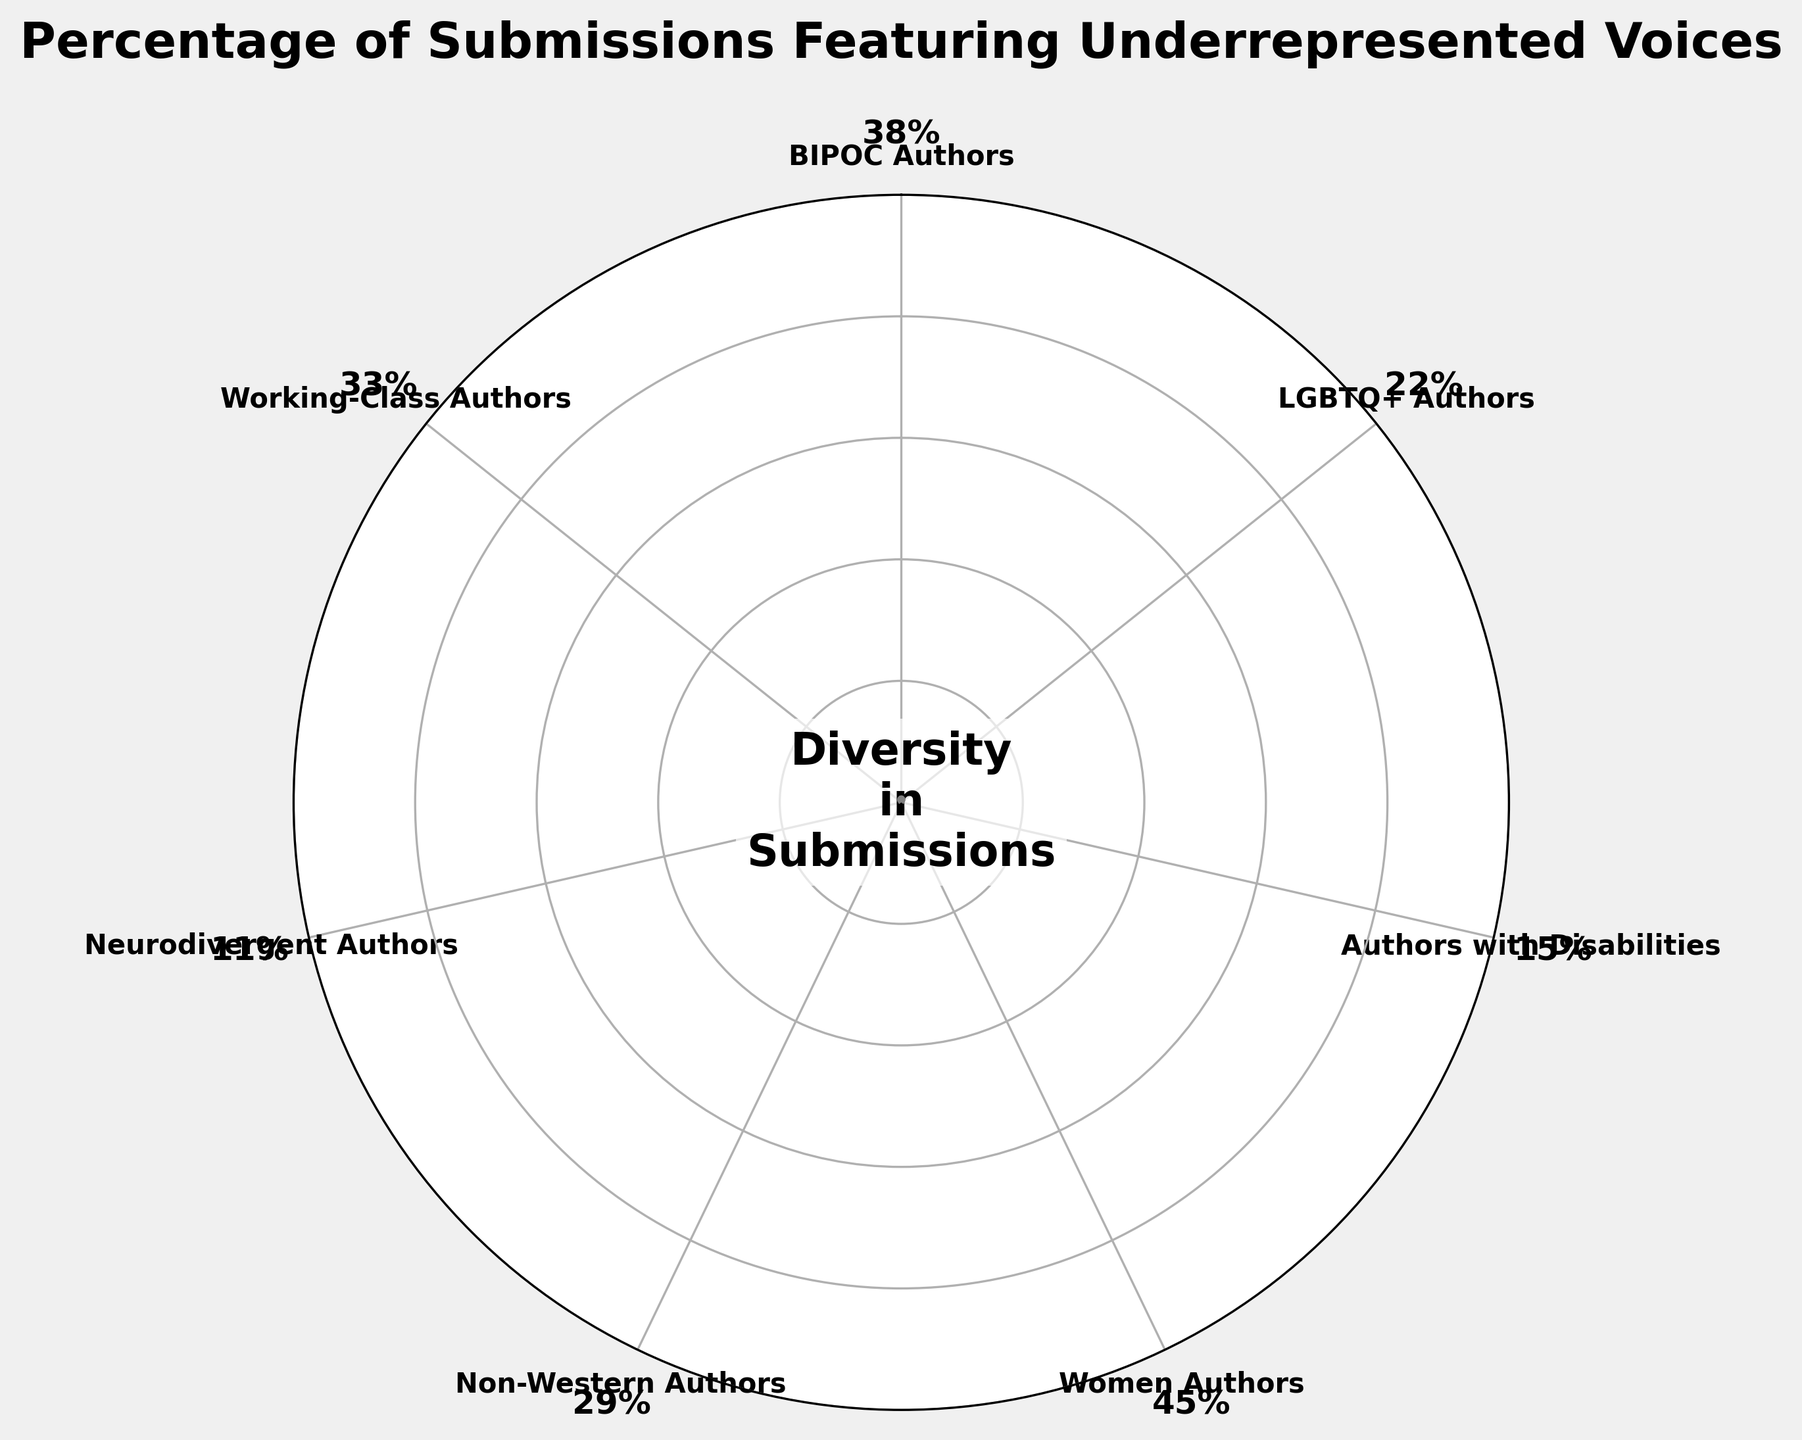What's the highest percentage shown in the chart for any category? The chart shows percentages for various categories, with the highest percentage marked clearly. Looking at the values, Women Authors have the highest percentage.
Answer: 45% Which category has the lowest representation in submissions based on the chart? The chart shows percentages for various categories, with Neurodivergent Authors having the lowest percentage.
Answer: Neurodivergent Authors How does the percentage of BIPOC Authors compare to the percentage of LGBTQ+ Authors? The percentage for BIPOC Authors is 38%, while for LGBTQ+ Authors, it is 22%. So, BIPOC Authors have a higher percentage.
Answer: BIPOC Authors have a higher percentage What's the sum of percentages for Neurodivergent Authors, Authors with Disabilities, and LGBTQ+ Authors? Adding the percentages for Neurodivergent Authors (11%), Authors with Disabilities (15%), and LGBTQ+ Authors (22%) gives 11 + 15 + 22 = 48.
Answer: 48% What is the average percentage for Work-Class Authors and Non-Western Authors? Adding the percentages for Working-Class Authors (33%) and Non-Western Authors (29%) results in 33 + 29 = 62. The average is 62 / 2 = 31.
Answer: 31 How many categories have a percentage higher than 30%? The chart shows percentages for different categories. BIPOC Authors (38%), Women Authors (45%), and Working-Class Authors (33%) all have percentages higher than 30%. This makes a total of 3 categories.
Answer: 3 Which two categories combined have a percentage closest to 50%? Comparing the percentages of categories, Authors with Disabilities (15%) and Non-Western Authors (29%) combine to 44%, which is closest to 50%.
Answer: Authors with Disabilities and Non-Western Authors Among the categories listed, which has the percentage closest to the average of all categories? First, calculate the average: (38 + 22 + 15 + 45 + 29 + 11 + 33) / 7 ≈ 27.57. Non-Western Authors, with 29%, is closest to the average.
Answer: Non-Western Authors 